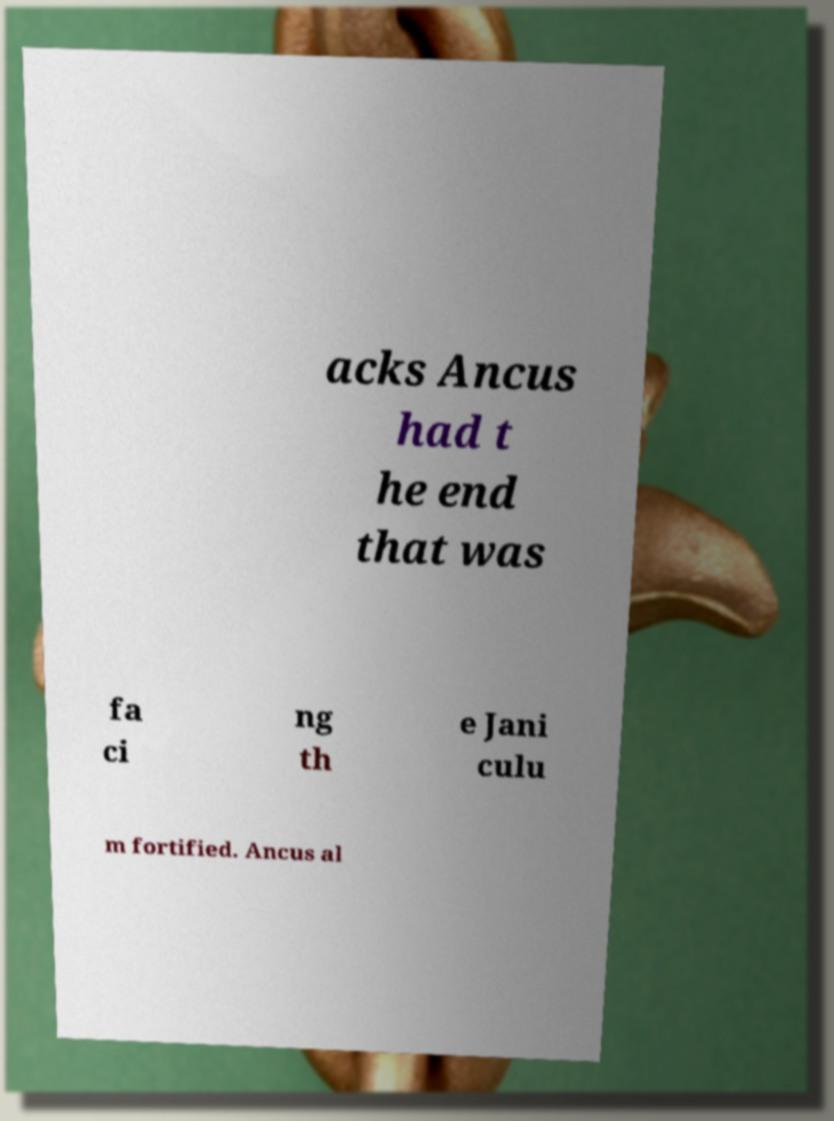For documentation purposes, I need the text within this image transcribed. Could you provide that? acks Ancus had t he end that was fa ci ng th e Jani culu m fortified. Ancus al 